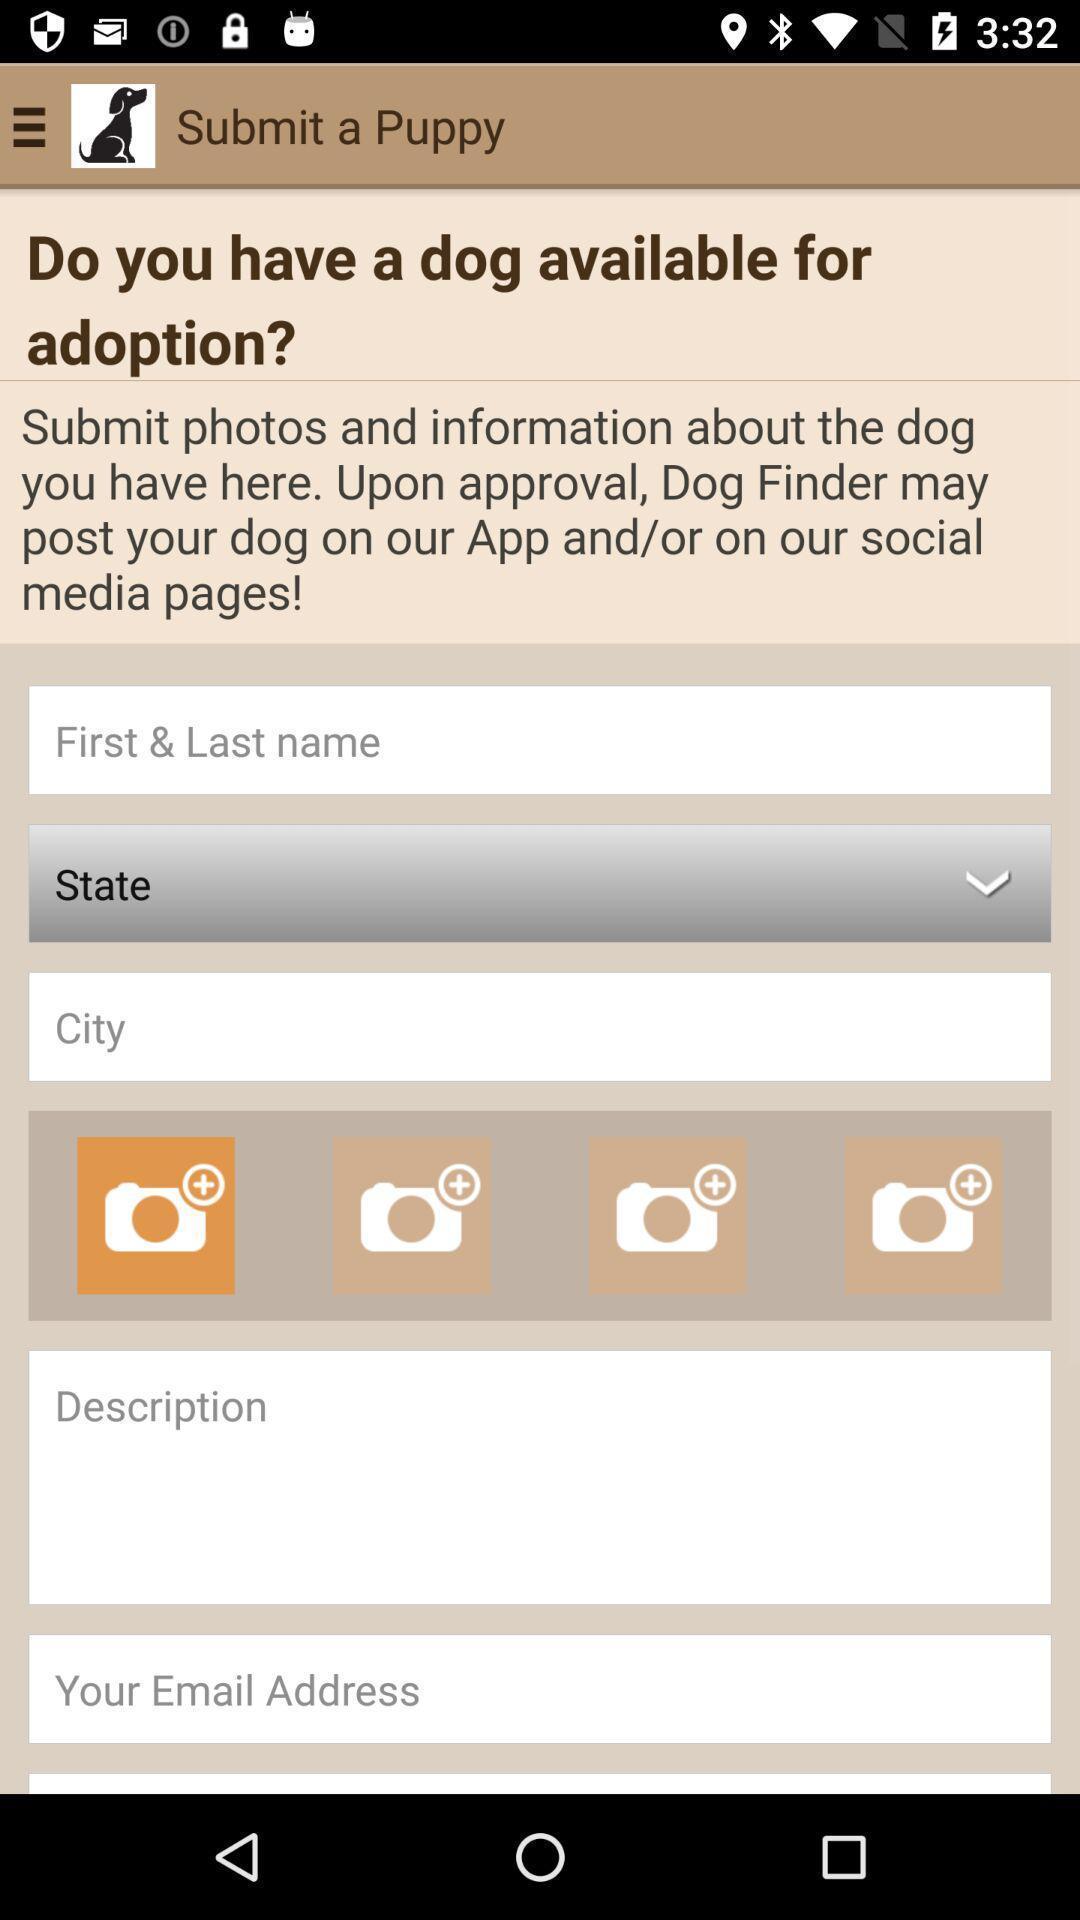What can you discern from this picture? Submit a puppy in the animal app. 